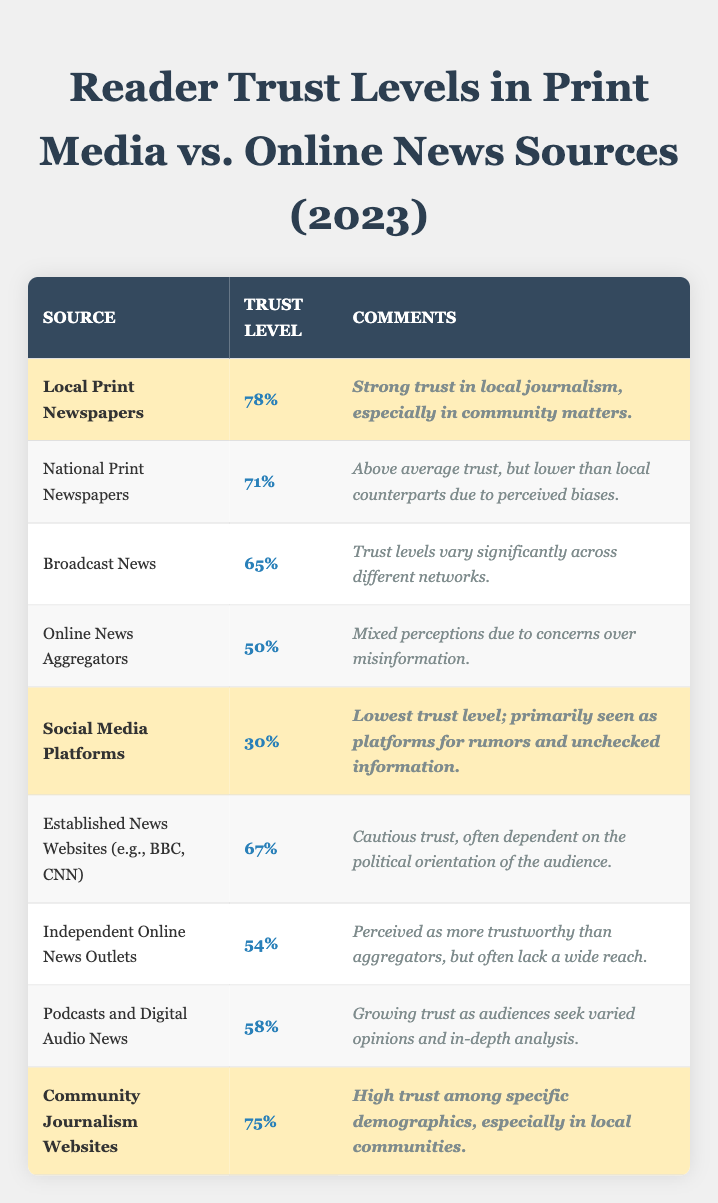What is the trust level percentage for Local Print Newspapers? The trust level percentage for Local Print Newspapers is explicitly stated in the table as 78%.
Answer: 78% Which news source has the lowest trust level? The table shows that Social Media Platforms have the lowest trust level at 30%.
Answer: 30% What is the trust level for National Print Newspapers compared to Established News Websites? National Print Newspapers have a trust level of 71%, while Established News Websites have a trust level of 67%. National Print Newspapers have a higher trust level by 4%.
Answer: 4% What is the average trust level for all the print media sources listed? The trust levels for print media are Local Print Newspapers (78%), National Print Newspapers (71%), and Community Journalism Websites (75%). The average is (78 + 71 + 75) / 3 = 74.67%, which can be rounded to 75%.
Answer: 75% Is the trust level for Broadcast News higher than that for Online News Aggregators? The trust level for Broadcast News is 65%, while Online News Aggregators have a trust level of 50%. Since 65% > 50%, the statement is true.
Answer: True What percentage of trust does Independent Online News Outlets have compared to Podcasts and Digital Audio News? Independent Online News Outlets have a trust level of 54%, while Podcasts and Digital Audio News have a trust level of 58%. Thus, Podcasts have a higher percentage than Independent Online News Outlets by 4%.
Answer: 4% Do community journalism websites have a higher trust level than online news aggregators? Community Journalism Websites have a trust level of 75%, while Online News Aggregators have 50%. Since 75% > 50%, the statement is true.
Answer: True What is the difference in trust level between the highest-rated source and the lowest-rated source? The highest-rated source is Local Print Newspapers at 78%, and the lowest-rated source is Social Media Platforms at 30%. The difference is 78% - 30% = 48%.
Answer: 48% How many sources have a trust level higher than 60%? The sources are Local Print Newspapers (78%), National Print Newspapers (71%), and Broadcast News (65%). This gives us three sources that meet the criteria.
Answer: 3 What can be inferred about the trust levels for digital platforms compared to print media? Comparing the trust levels, Local Print Newspapers (78%) and Community Journalism Websites (75%) show significantly higher trust than the digital platforms, like Social Media Platforms (30%) and Online News Aggregators (50%). This suggests a general lower trust in digital platforms compared to print.
Answer: Higher trust for print media 